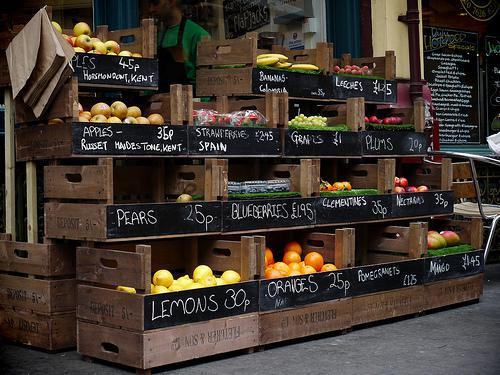Question: what is in the crates?
Choices:
A. Vegetables.
B. Rice.
C. Fruit.
D. Meat.
Answer with the letter. Answer: C Question: what is for sale?
Choices:
A. Meat.
B. Rice.
C. Flowers.
D. Produce.
Answer with the letter. Answer: D Question: where are the lemons?
Choices:
A. Beside the apples.
B. In the bag.
C. Under the pears.
D. Behind the bananas.
Answer with the letter. Answer: C Question: where are the bananas?
Choices:
A. In the bag.
B. Next to the apples.
C. In the refrigerator.
D. In the top row of crates.
Answer with the letter. Answer: D Question: how much are pears?
Choices:
A. One dollar.
B. 25 pence.
C. 50 cents.
D. One pound.
Answer with the letter. Answer: B Question: why are prices listed?
Choices:
A. To let people know how much to pay.
B. To demonstrate prices.
C. To show how much the fruit costs.
D. To demonstrate worth.
Answer with the letter. Answer: C 